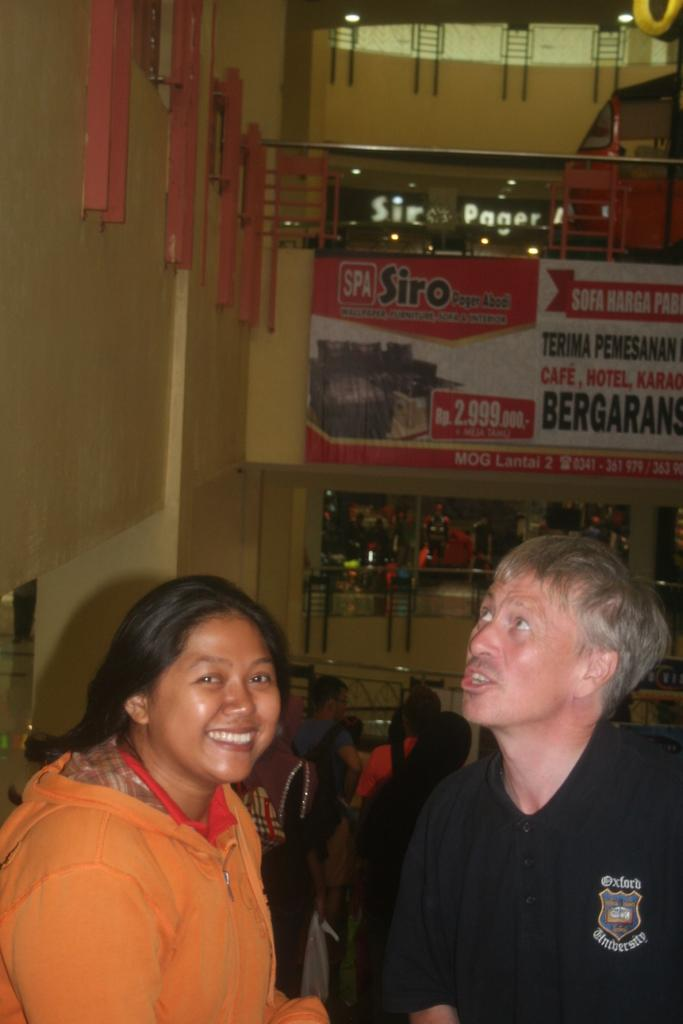Who are the two main subjects in the image? There is a woman and a man in the image. What can be seen in the background of the image? There are many people in the background of the image. What is one feature of the setting in the image? There is a wall in the image. What is hanging on the wall in the image? There is a banner with writing in the image. What type of milk is being served at the event depicted in the image? There is no milk or event depicted in the image; it only shows a woman, a man, and a banner with writing on a wall. 